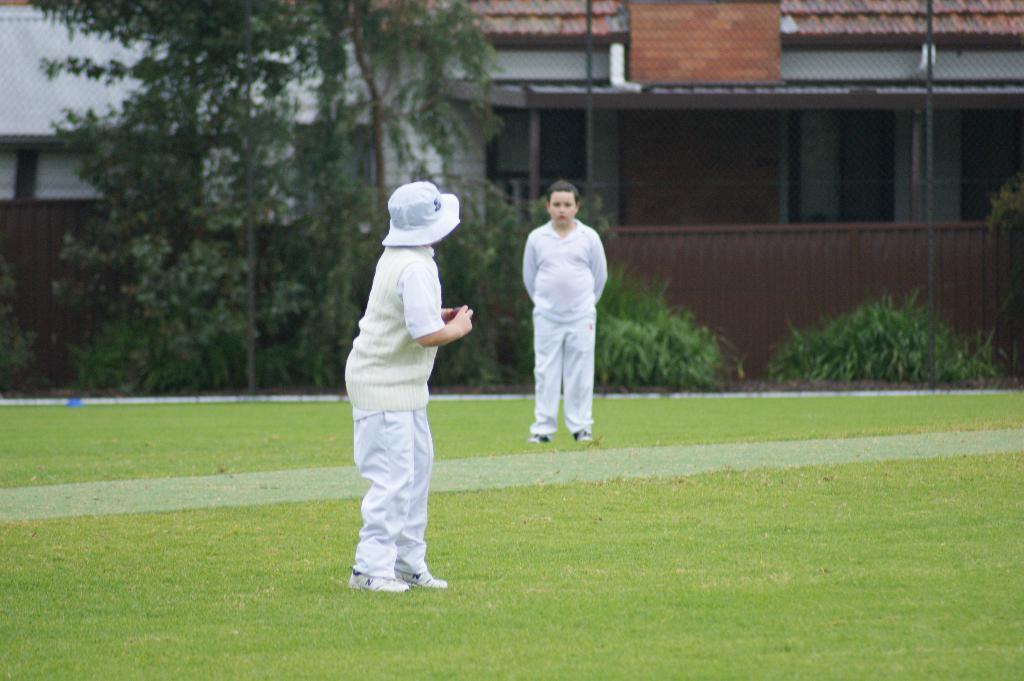Describe this image in one or two sentences. There are two kids standing and this kid holding a ball and we can see grass. In the background we can see trees,plants,fence,board and house. 